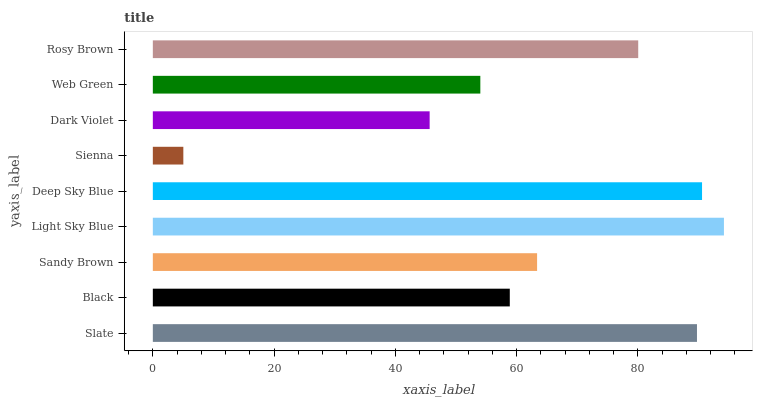Is Sienna the minimum?
Answer yes or no. Yes. Is Light Sky Blue the maximum?
Answer yes or no. Yes. Is Black the minimum?
Answer yes or no. No. Is Black the maximum?
Answer yes or no. No. Is Slate greater than Black?
Answer yes or no. Yes. Is Black less than Slate?
Answer yes or no. Yes. Is Black greater than Slate?
Answer yes or no. No. Is Slate less than Black?
Answer yes or no. No. Is Sandy Brown the high median?
Answer yes or no. Yes. Is Sandy Brown the low median?
Answer yes or no. Yes. Is Light Sky Blue the high median?
Answer yes or no. No. Is Dark Violet the low median?
Answer yes or no. No. 